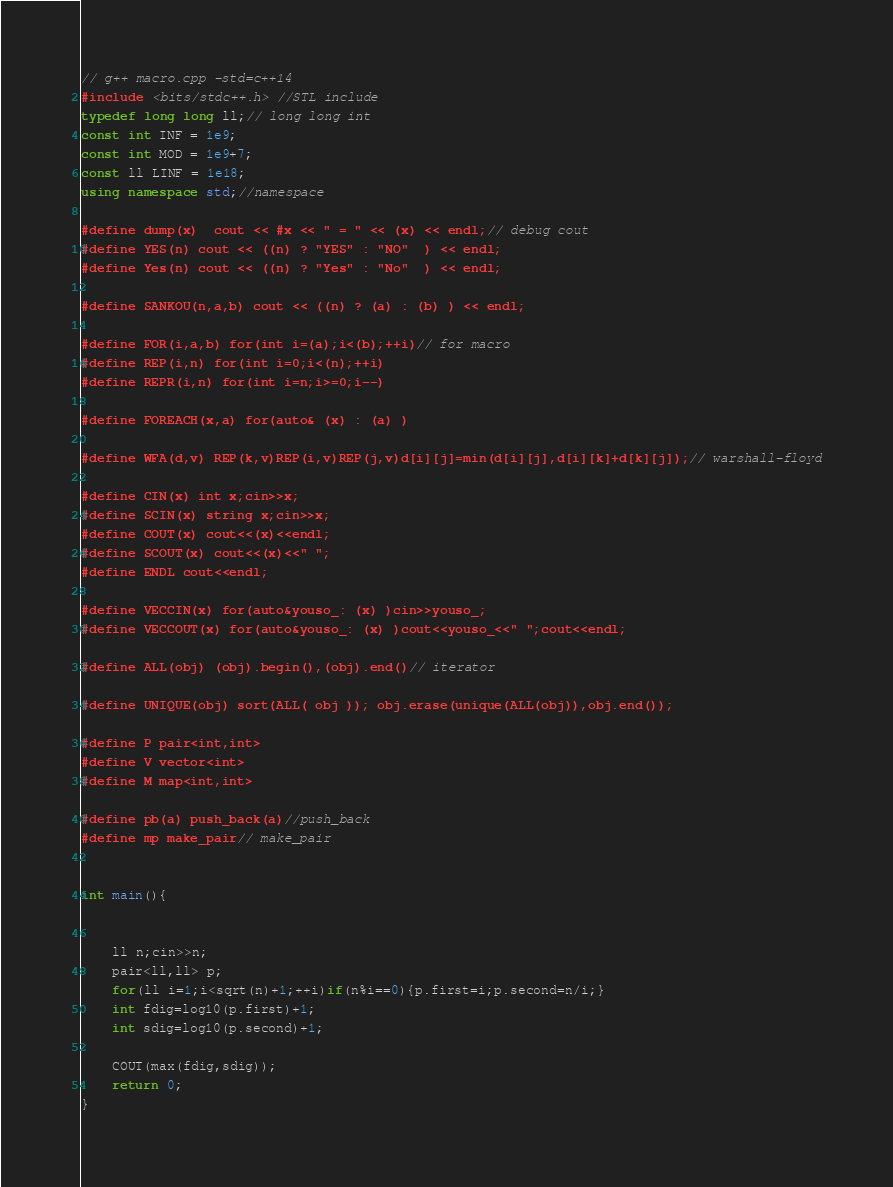<code> <loc_0><loc_0><loc_500><loc_500><_C++_>// g++ macro.cpp -std=c++14
#include <bits/stdc++.h> //STL include
typedef long long ll;// long long int
const int INF = 1e9;
const int MOD = 1e9+7;
const ll LINF = 1e18;
using namespace std;//namespace

#define dump(x)  cout << #x << " = " << (x) << endl;// debug cout
#define YES(n) cout << ((n) ? "YES" : "NO"  ) << endl;
#define Yes(n) cout << ((n) ? "Yes" : "No"  ) << endl;

#define SANKOU(n,a,b) cout << ((n) ? (a) : (b) ) << endl;

#define FOR(i,a,b) for(int i=(a);i<(b);++i)// for macro
#define REP(i,n) for(int i=0;i<(n);++i)
#define REPR(i,n) for(int i=n;i>=0;i--)

#define FOREACH(x,a) for(auto& (x) : (a) )

#define WFA(d,v) REP(k,v)REP(i,v)REP(j,v)d[i][j]=min(d[i][j],d[i][k]+d[k][j]);// warshall-floyd

#define CIN(x) int x;cin>>x;
#define SCIN(x) string x;cin>>x;
#define COUT(x) cout<<(x)<<endl;
#define SCOUT(x) cout<<(x)<<" ";
#define ENDL cout<<endl;

#define VECCIN(x) for(auto&youso_: (x) )cin>>youso_;
#define VECCOUT(x) for(auto&youso_: (x) )cout<<youso_<<" ";cout<<endl;

#define ALL(obj) (obj).begin(),(obj).end()// iterator

#define UNIQUE(obj) sort(ALL( obj )); obj.erase(unique(ALL(obj)),obj.end());

#define P pair<int,int>
#define V vector<int>
#define M map<int,int>

#define pb(a) push_back(a)//push_back
#define mp make_pair// make_pair


int main(){


    ll n;cin>>n;
    pair<ll,ll> p;
    for(ll i=1;i<sqrt(n)+1;++i)if(n%i==0){p.first=i;p.second=n/i;}
    int fdig=log10(p.first)+1;
    int sdig=log10(p.second)+1;

    COUT(max(fdig,sdig));
    return 0;
}
</code> 